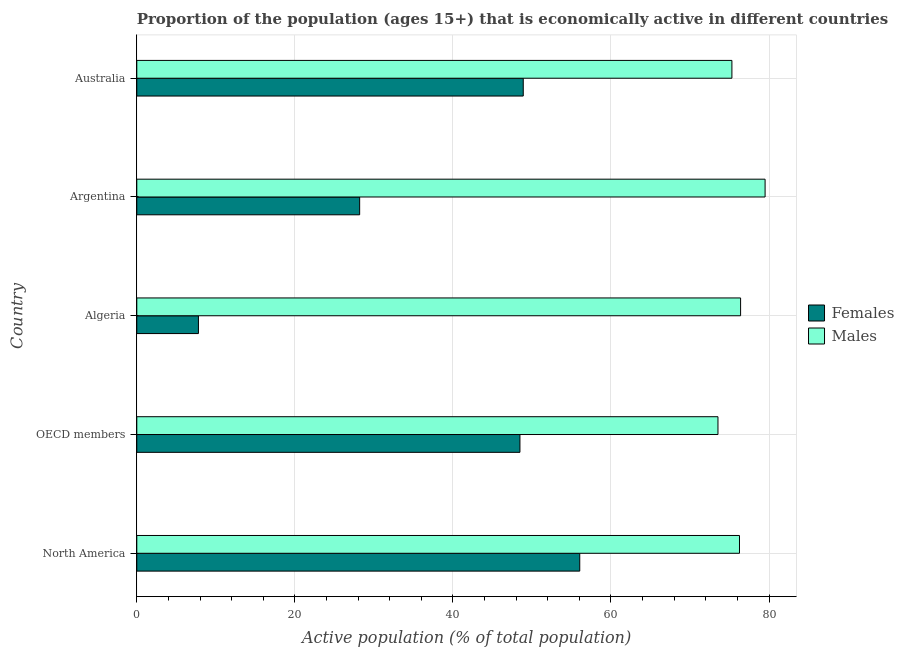Are the number of bars per tick equal to the number of legend labels?
Offer a terse response. Yes. How many bars are there on the 3rd tick from the bottom?
Make the answer very short. 2. In how many cases, is the number of bars for a given country not equal to the number of legend labels?
Keep it short and to the point. 0. What is the percentage of economically active male population in OECD members?
Your answer should be very brief. 73.54. Across all countries, what is the maximum percentage of economically active female population?
Offer a very short reply. 56.05. Across all countries, what is the minimum percentage of economically active female population?
Provide a short and direct response. 7.8. In which country was the percentage of economically active female population maximum?
Offer a very short reply. North America. In which country was the percentage of economically active female population minimum?
Make the answer very short. Algeria. What is the total percentage of economically active female population in the graph?
Your response must be concise. 189.43. What is the difference between the percentage of economically active female population in OECD members and the percentage of economically active male population in Algeria?
Ensure brevity in your answer.  -27.92. What is the average percentage of economically active female population per country?
Provide a succinct answer. 37.89. What is the difference between the percentage of economically active male population and percentage of economically active female population in Algeria?
Ensure brevity in your answer.  68.6. What is the ratio of the percentage of economically active male population in Argentina to that in OECD members?
Make the answer very short. 1.08. Is the percentage of economically active female population in Algeria less than that in Argentina?
Keep it short and to the point. Yes. Is the difference between the percentage of economically active female population in Algeria and Australia greater than the difference between the percentage of economically active male population in Algeria and Australia?
Offer a terse response. No. What is the difference between the highest and the second highest percentage of economically active female population?
Provide a short and direct response. 7.15. What is the difference between the highest and the lowest percentage of economically active male population?
Offer a very short reply. 5.96. Is the sum of the percentage of economically active male population in Australia and North America greater than the maximum percentage of economically active female population across all countries?
Give a very brief answer. Yes. What does the 2nd bar from the top in North America represents?
Give a very brief answer. Females. What does the 2nd bar from the bottom in OECD members represents?
Provide a succinct answer. Males. Are all the bars in the graph horizontal?
Your response must be concise. Yes. How many countries are there in the graph?
Your answer should be compact. 5. Does the graph contain any zero values?
Your answer should be compact. No. How many legend labels are there?
Offer a terse response. 2. How are the legend labels stacked?
Ensure brevity in your answer.  Vertical. What is the title of the graph?
Provide a short and direct response. Proportion of the population (ages 15+) that is economically active in different countries. What is the label or title of the X-axis?
Your response must be concise. Active population (% of total population). What is the Active population (% of total population) in Females in North America?
Your answer should be very brief. 56.05. What is the Active population (% of total population) in Males in North America?
Make the answer very short. 76.26. What is the Active population (% of total population) in Females in OECD members?
Your response must be concise. 48.48. What is the Active population (% of total population) of Males in OECD members?
Make the answer very short. 73.54. What is the Active population (% of total population) in Females in Algeria?
Offer a terse response. 7.8. What is the Active population (% of total population) of Males in Algeria?
Your answer should be very brief. 76.4. What is the Active population (% of total population) in Females in Argentina?
Give a very brief answer. 28.2. What is the Active population (% of total population) in Males in Argentina?
Provide a short and direct response. 79.5. What is the Active population (% of total population) of Females in Australia?
Your answer should be compact. 48.9. What is the Active population (% of total population) in Males in Australia?
Give a very brief answer. 75.3. Across all countries, what is the maximum Active population (% of total population) of Females?
Your response must be concise. 56.05. Across all countries, what is the maximum Active population (% of total population) in Males?
Give a very brief answer. 79.5. Across all countries, what is the minimum Active population (% of total population) in Females?
Ensure brevity in your answer.  7.8. Across all countries, what is the minimum Active population (% of total population) of Males?
Your answer should be compact. 73.54. What is the total Active population (% of total population) in Females in the graph?
Provide a short and direct response. 189.43. What is the total Active population (% of total population) of Males in the graph?
Provide a short and direct response. 381. What is the difference between the Active population (% of total population) of Females in North America and that in OECD members?
Offer a terse response. 7.57. What is the difference between the Active population (% of total population) of Males in North America and that in OECD members?
Make the answer very short. 2.72. What is the difference between the Active population (% of total population) of Females in North America and that in Algeria?
Provide a short and direct response. 48.25. What is the difference between the Active population (% of total population) of Males in North America and that in Algeria?
Keep it short and to the point. -0.14. What is the difference between the Active population (% of total population) in Females in North America and that in Argentina?
Give a very brief answer. 27.85. What is the difference between the Active population (% of total population) in Males in North America and that in Argentina?
Offer a very short reply. -3.24. What is the difference between the Active population (% of total population) of Females in North America and that in Australia?
Provide a short and direct response. 7.15. What is the difference between the Active population (% of total population) in Males in North America and that in Australia?
Your answer should be very brief. 0.96. What is the difference between the Active population (% of total population) in Females in OECD members and that in Algeria?
Your answer should be compact. 40.68. What is the difference between the Active population (% of total population) in Males in OECD members and that in Algeria?
Ensure brevity in your answer.  -2.86. What is the difference between the Active population (% of total population) of Females in OECD members and that in Argentina?
Give a very brief answer. 20.28. What is the difference between the Active population (% of total population) of Males in OECD members and that in Argentina?
Provide a short and direct response. -5.96. What is the difference between the Active population (% of total population) of Females in OECD members and that in Australia?
Provide a succinct answer. -0.42. What is the difference between the Active population (% of total population) of Males in OECD members and that in Australia?
Ensure brevity in your answer.  -1.76. What is the difference between the Active population (% of total population) of Females in Algeria and that in Argentina?
Offer a very short reply. -20.4. What is the difference between the Active population (% of total population) of Males in Algeria and that in Argentina?
Make the answer very short. -3.1. What is the difference between the Active population (% of total population) in Females in Algeria and that in Australia?
Offer a terse response. -41.1. What is the difference between the Active population (% of total population) in Males in Algeria and that in Australia?
Provide a succinct answer. 1.1. What is the difference between the Active population (% of total population) of Females in Argentina and that in Australia?
Your answer should be very brief. -20.7. What is the difference between the Active population (% of total population) of Females in North America and the Active population (% of total population) of Males in OECD members?
Ensure brevity in your answer.  -17.49. What is the difference between the Active population (% of total population) of Females in North America and the Active population (% of total population) of Males in Algeria?
Give a very brief answer. -20.35. What is the difference between the Active population (% of total population) in Females in North America and the Active population (% of total population) in Males in Argentina?
Your answer should be very brief. -23.45. What is the difference between the Active population (% of total population) of Females in North America and the Active population (% of total population) of Males in Australia?
Offer a terse response. -19.25. What is the difference between the Active population (% of total population) in Females in OECD members and the Active population (% of total population) in Males in Algeria?
Ensure brevity in your answer.  -27.92. What is the difference between the Active population (% of total population) of Females in OECD members and the Active population (% of total population) of Males in Argentina?
Your response must be concise. -31.02. What is the difference between the Active population (% of total population) of Females in OECD members and the Active population (% of total population) of Males in Australia?
Ensure brevity in your answer.  -26.82. What is the difference between the Active population (% of total population) of Females in Algeria and the Active population (% of total population) of Males in Argentina?
Offer a very short reply. -71.7. What is the difference between the Active population (% of total population) in Females in Algeria and the Active population (% of total population) in Males in Australia?
Your answer should be compact. -67.5. What is the difference between the Active population (% of total population) in Females in Argentina and the Active population (% of total population) in Males in Australia?
Keep it short and to the point. -47.1. What is the average Active population (% of total population) in Females per country?
Ensure brevity in your answer.  37.89. What is the average Active population (% of total population) of Males per country?
Ensure brevity in your answer.  76.2. What is the difference between the Active population (% of total population) of Females and Active population (% of total population) of Males in North America?
Ensure brevity in your answer.  -20.21. What is the difference between the Active population (% of total population) of Females and Active population (% of total population) of Males in OECD members?
Offer a very short reply. -25.06. What is the difference between the Active population (% of total population) in Females and Active population (% of total population) in Males in Algeria?
Your response must be concise. -68.6. What is the difference between the Active population (% of total population) of Females and Active population (% of total population) of Males in Argentina?
Offer a very short reply. -51.3. What is the difference between the Active population (% of total population) of Females and Active population (% of total population) of Males in Australia?
Your response must be concise. -26.4. What is the ratio of the Active population (% of total population) in Females in North America to that in OECD members?
Keep it short and to the point. 1.16. What is the ratio of the Active population (% of total population) in Females in North America to that in Algeria?
Your answer should be compact. 7.19. What is the ratio of the Active population (% of total population) of Males in North America to that in Algeria?
Make the answer very short. 1. What is the ratio of the Active population (% of total population) in Females in North America to that in Argentina?
Make the answer very short. 1.99. What is the ratio of the Active population (% of total population) in Males in North America to that in Argentina?
Provide a short and direct response. 0.96. What is the ratio of the Active population (% of total population) of Females in North America to that in Australia?
Ensure brevity in your answer.  1.15. What is the ratio of the Active population (% of total population) of Males in North America to that in Australia?
Your answer should be compact. 1.01. What is the ratio of the Active population (% of total population) of Females in OECD members to that in Algeria?
Provide a succinct answer. 6.22. What is the ratio of the Active population (% of total population) in Males in OECD members to that in Algeria?
Provide a succinct answer. 0.96. What is the ratio of the Active population (% of total population) of Females in OECD members to that in Argentina?
Your answer should be very brief. 1.72. What is the ratio of the Active population (% of total population) in Males in OECD members to that in Argentina?
Your answer should be very brief. 0.93. What is the ratio of the Active population (% of total population) in Males in OECD members to that in Australia?
Your response must be concise. 0.98. What is the ratio of the Active population (% of total population) of Females in Algeria to that in Argentina?
Keep it short and to the point. 0.28. What is the ratio of the Active population (% of total population) in Females in Algeria to that in Australia?
Offer a terse response. 0.16. What is the ratio of the Active population (% of total population) of Males in Algeria to that in Australia?
Provide a succinct answer. 1.01. What is the ratio of the Active population (% of total population) in Females in Argentina to that in Australia?
Your answer should be very brief. 0.58. What is the ratio of the Active population (% of total population) in Males in Argentina to that in Australia?
Give a very brief answer. 1.06. What is the difference between the highest and the second highest Active population (% of total population) in Females?
Your answer should be very brief. 7.15. What is the difference between the highest and the second highest Active population (% of total population) in Males?
Provide a short and direct response. 3.1. What is the difference between the highest and the lowest Active population (% of total population) of Females?
Your answer should be compact. 48.25. What is the difference between the highest and the lowest Active population (% of total population) in Males?
Offer a very short reply. 5.96. 